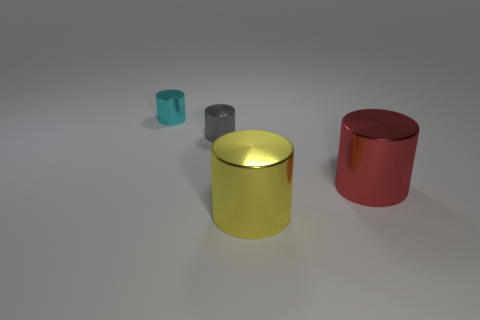What number of matte objects are either cylinders or tiny yellow balls?
Provide a succinct answer. 0. There is a large yellow shiny thing in front of the big cylinder that is on the right side of the yellow thing; is there a large red metallic thing that is in front of it?
Offer a terse response. No. There is a small cyan metallic thing; what number of cyan metallic objects are in front of it?
Give a very brief answer. 0. How many tiny things are yellow objects or blue things?
Offer a very short reply. 0. What shape is the big yellow metal thing on the right side of the small cyan cylinder?
Your response must be concise. Cylinder. There is a metal cylinder that is in front of the red metallic cylinder; is its size the same as the red metallic cylinder that is in front of the small gray metallic object?
Your answer should be compact. Yes. Are there more red metal cylinders to the right of the large red object than gray cylinders to the left of the gray cylinder?
Ensure brevity in your answer.  No. Is there a tiny cylinder made of the same material as the small cyan thing?
Make the answer very short. Yes. How many big brown rubber objects are the same shape as the large yellow shiny object?
Give a very brief answer. 0. Is the material of the small thing that is in front of the cyan object the same as the object to the left of the tiny gray thing?
Provide a short and direct response. Yes. 